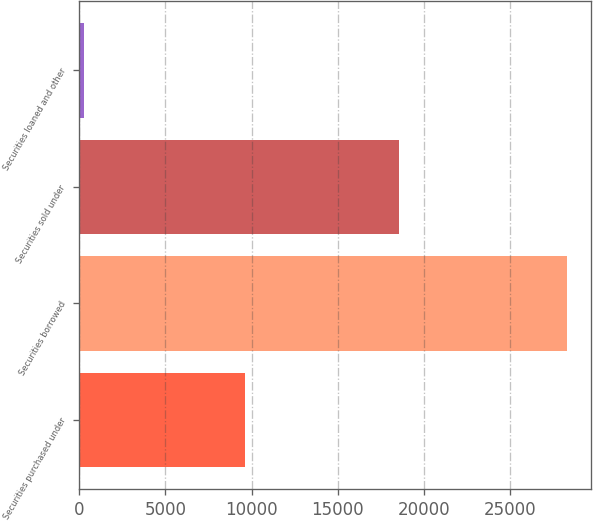Convert chart to OTSL. <chart><loc_0><loc_0><loc_500><loc_500><bar_chart><fcel>Securities purchased under<fcel>Securities borrowed<fcel>Securities sold under<fcel>Securities loaned and other<nl><fcel>9601<fcel>28307<fcel>18535<fcel>263<nl></chart> 